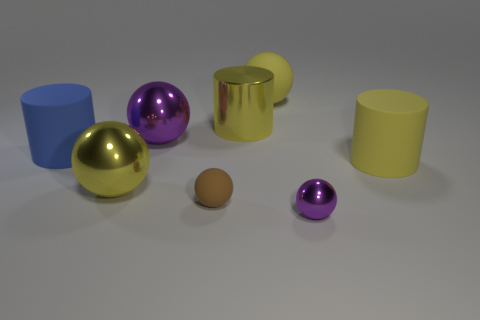Subtract 1 balls. How many balls are left? 4 Subtract all yellow balls. How many balls are left? 3 Subtract all large yellow shiny balls. How many balls are left? 4 Add 1 yellow rubber spheres. How many objects exist? 9 Subtract all yellow spheres. Subtract all cyan cubes. How many spheres are left? 3 Subtract all spheres. How many objects are left? 3 Add 5 big yellow spheres. How many big yellow spheres are left? 7 Add 4 large blue rubber cylinders. How many large blue rubber cylinders exist? 5 Subtract 1 purple spheres. How many objects are left? 7 Subtract all gray rubber cylinders. Subtract all big matte things. How many objects are left? 5 